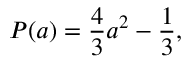Convert formula to latex. <formula><loc_0><loc_0><loc_500><loc_500>P ( a ) = \frac { 4 } { 3 } a ^ { 2 } - \frac { 1 } { 3 } ,</formula> 